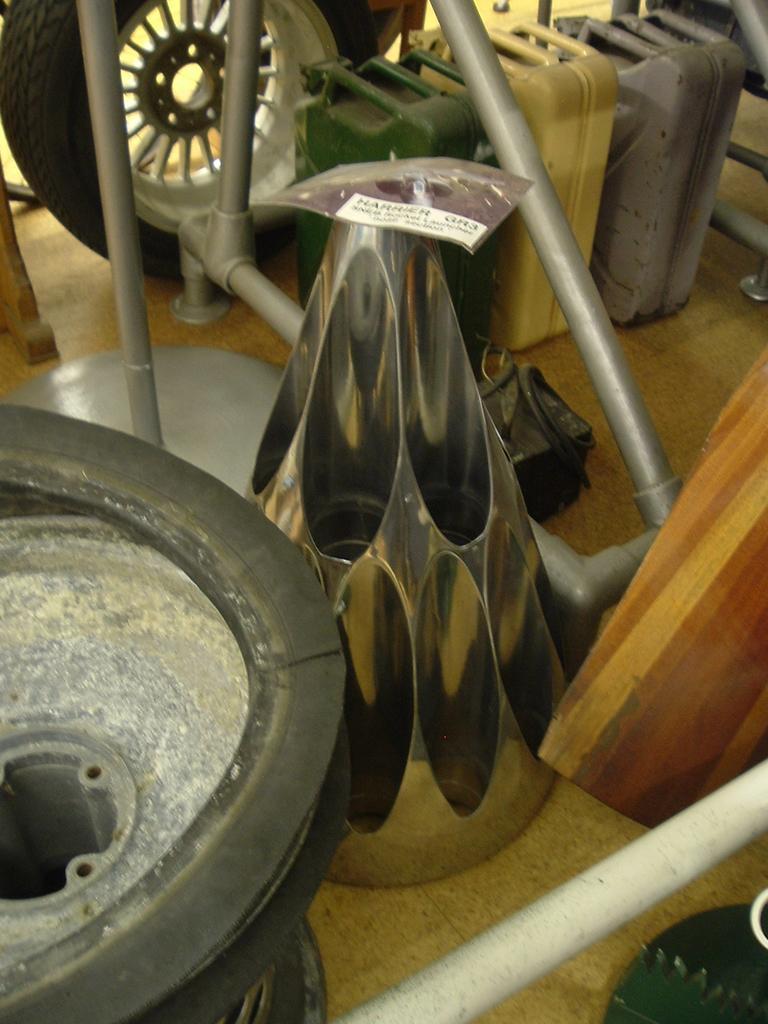How would you summarize this image in a sentence or two? In this image, we can see wheels, cans, wood, stands and in the center we can see a cone shaped object. At the bottom, there is floor. 